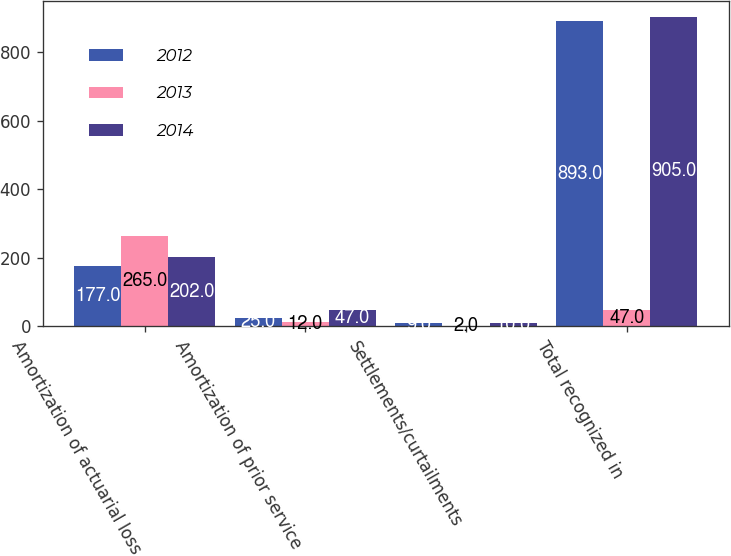<chart> <loc_0><loc_0><loc_500><loc_500><stacked_bar_chart><ecel><fcel>Amortization of actuarial loss<fcel>Amortization of prior service<fcel>Settlements/curtailments<fcel>Total recognized in<nl><fcel>2012<fcel>177<fcel>25<fcel>9<fcel>893<nl><fcel>2013<fcel>265<fcel>12<fcel>2<fcel>47<nl><fcel>2014<fcel>202<fcel>47<fcel>10<fcel>905<nl></chart> 